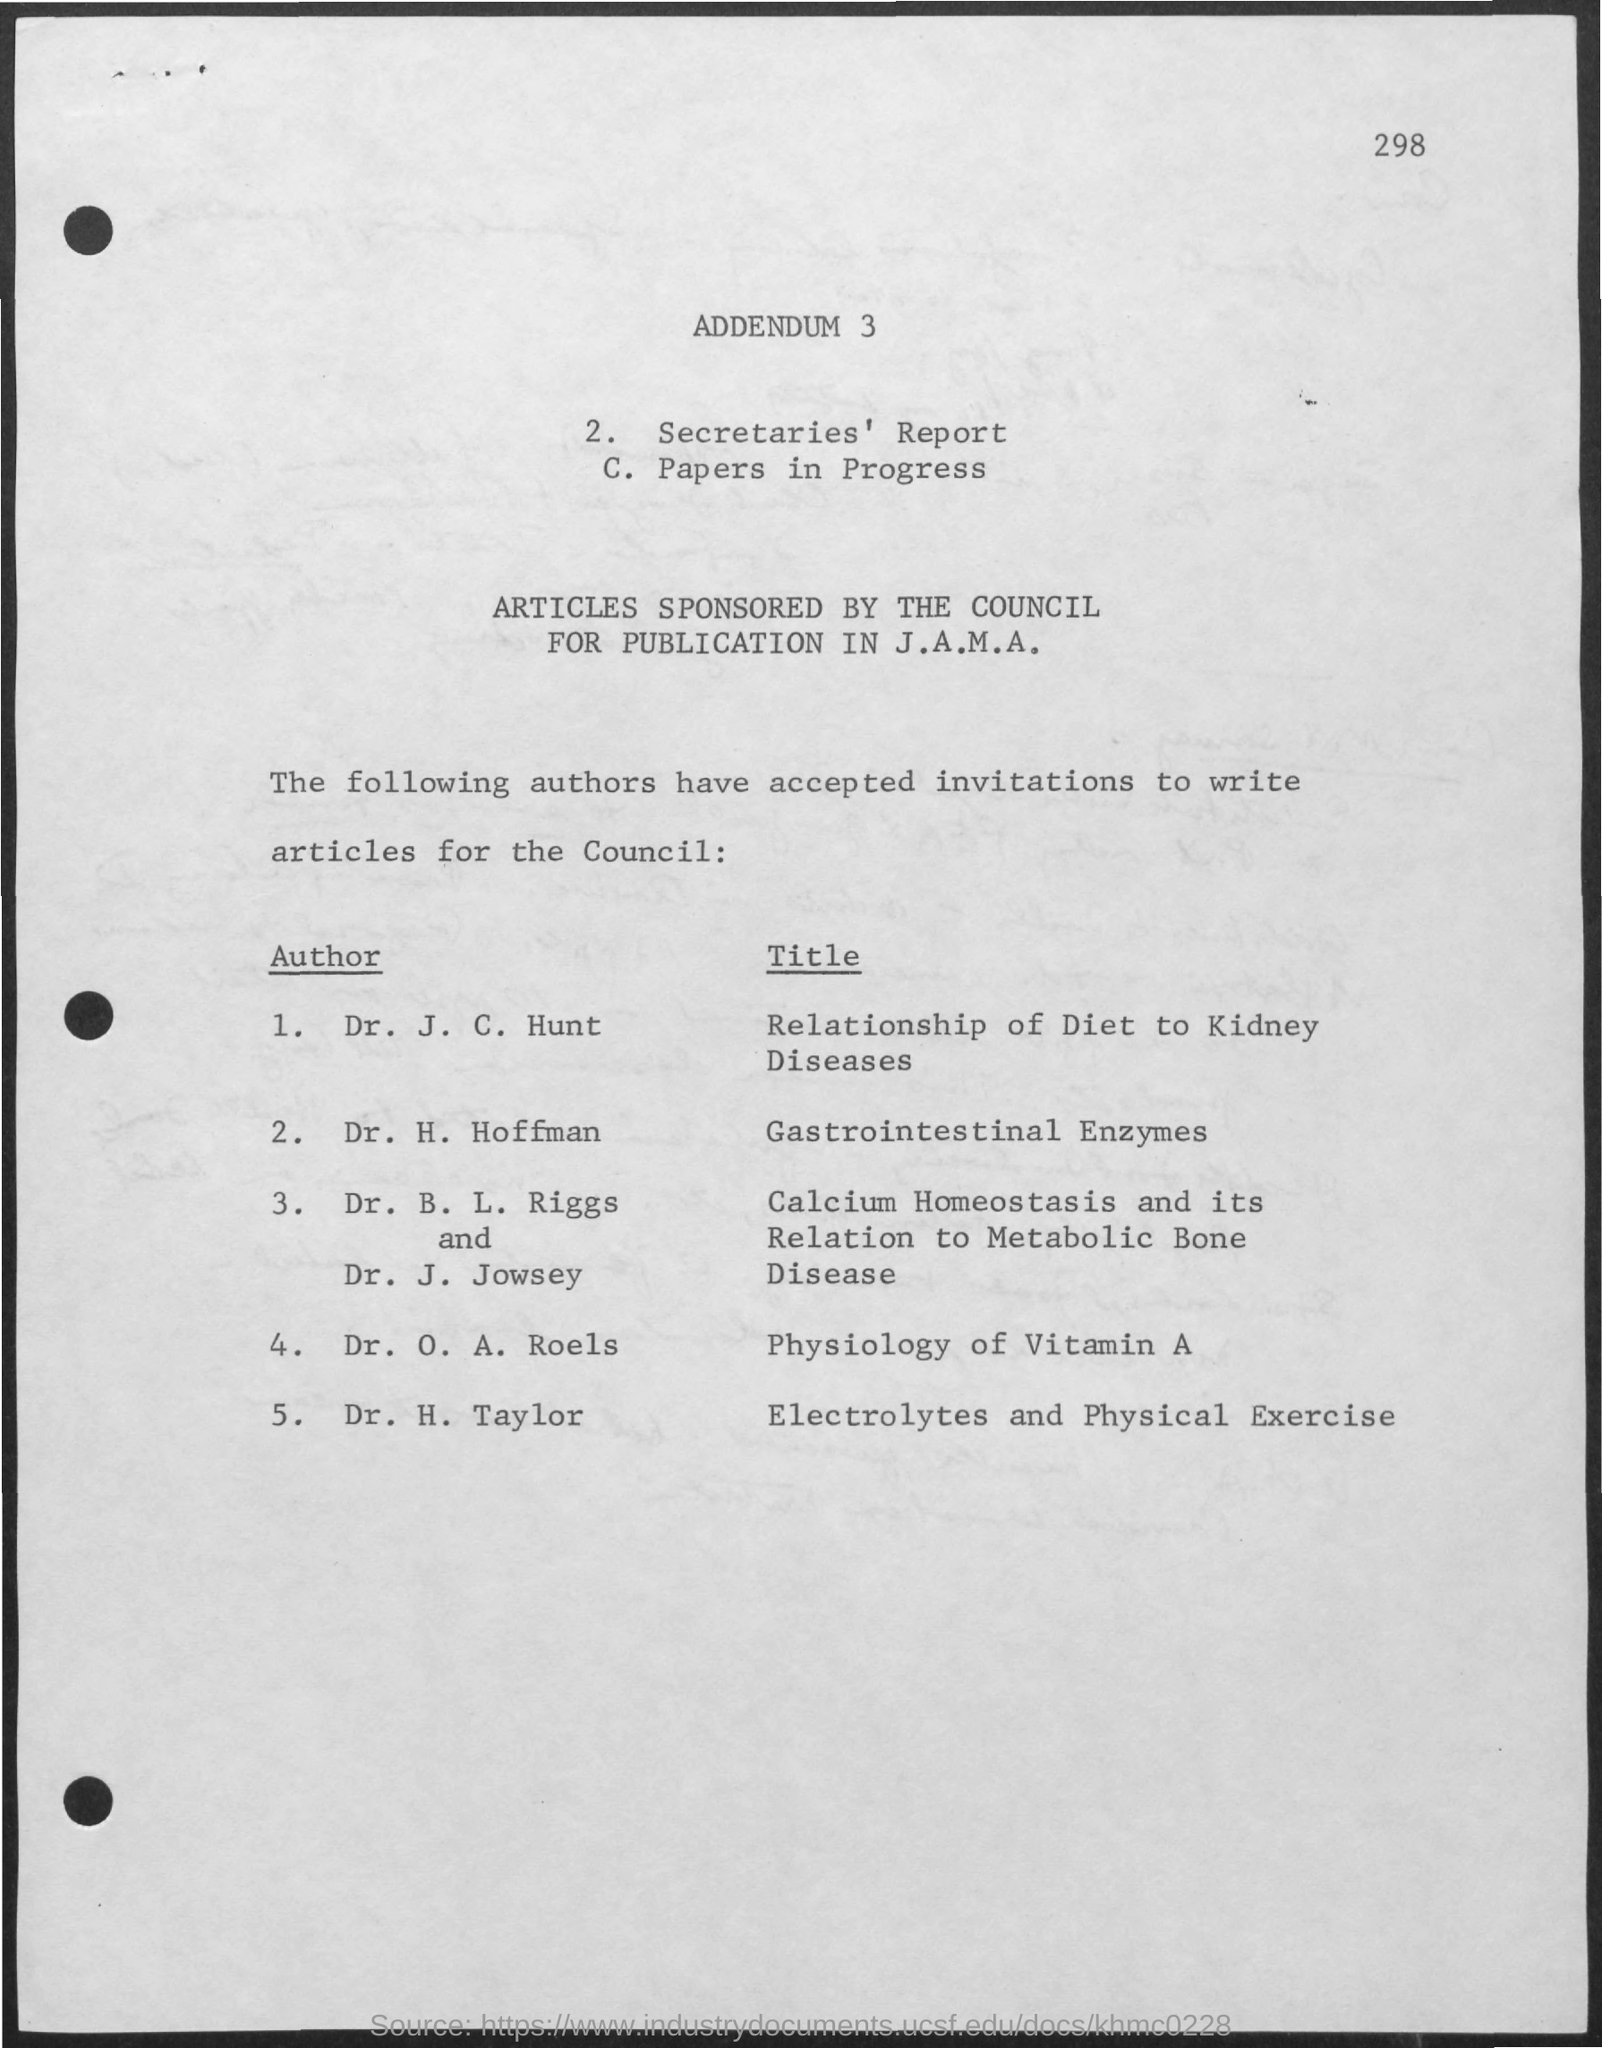Who is the author for "Gastrointestinal Enzymes"?
Ensure brevity in your answer.  H. hoffman. Who is the author for "Physiology of Vitamin A"?
Your answer should be very brief. Dr. O. A. Roels. 